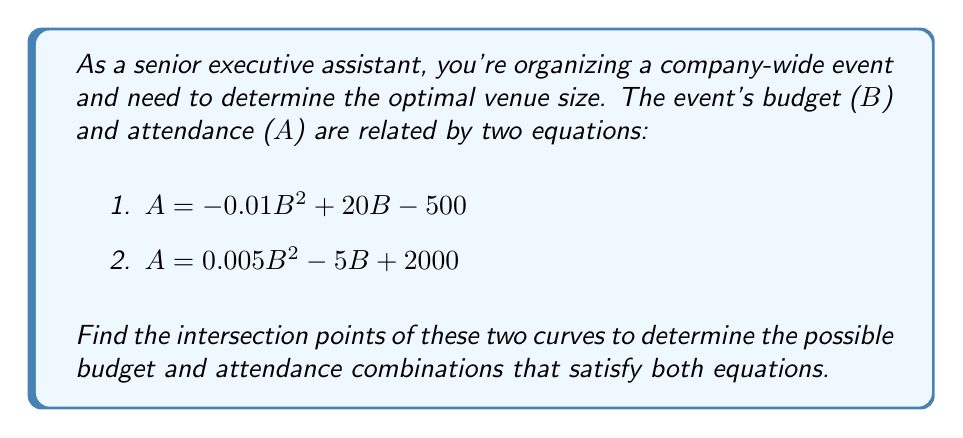Solve this math problem. Let's approach this step-by-step:

1) First, we need to set the two equations equal to each other since we're looking for points where they intersect:

   $-0.01B^2 + 20B - 500 = 0.005B^2 - 5B + 2000$

2) Rearrange the equation so all terms are on one side:

   $-0.015B^2 + 25B - 2500 = 0$

3) This is a quadratic equation in the form $aB^2 + bB + c = 0$, where:
   $a = -0.015$
   $b = 25$
   $c = -2500$

4) We can solve this using the quadratic formula: $B = \frac{-b \pm \sqrt{b^2 - 4ac}}{2a}$

5) Substituting our values:

   $B = \frac{-25 \pm \sqrt{25^2 - 4(-0.015)(-2500)}}{2(-0.015)}$

6) Simplify:

   $B = \frac{-25 \pm \sqrt{625 - 150}}{-0.03} = \frac{-25 \pm \sqrt{475}}{-0.03}$

7) Calculate:

   $B \approx 1000$ or $B \approx 666.67$

8) To find the corresponding $A$ values, substitute these $B$ values into either of the original equations. Let's use the first one:

   For $B = 1000$: $A = -0.01(1000)^2 + 20(1000) - 500 = 9500$
   For $B = 666.67$: $A = -0.01(666.67)^2 + 20(666.67) - 500 \approx 7777.78$

Therefore, the intersection points are approximately (1000, 9500) and (666.67, 7777.78).
Answer: (1000, 9500) and (666.67, 7777.78) 